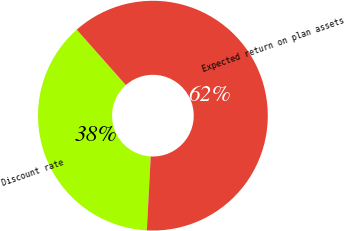Convert chart to OTSL. <chart><loc_0><loc_0><loc_500><loc_500><pie_chart><fcel>Discount rate<fcel>Expected return on plan assets<nl><fcel>37.62%<fcel>62.38%<nl></chart> 